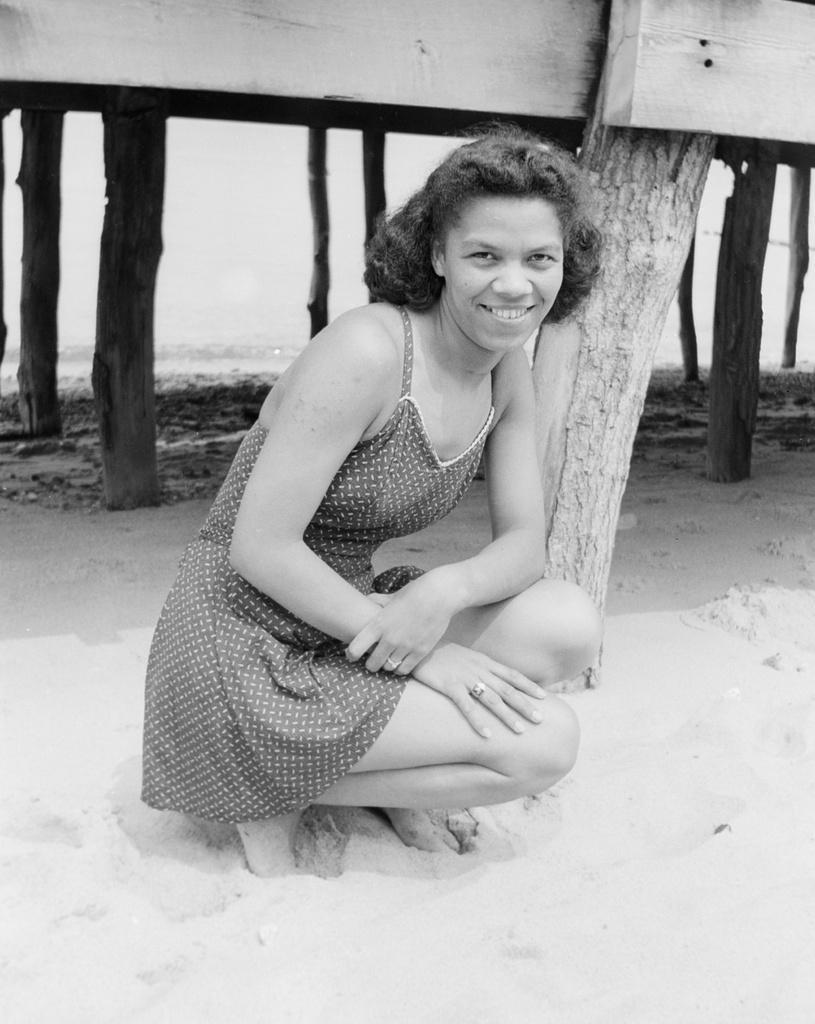Can you describe this image briefly? In this image I can see a woman and I can see smile on her face. In the background I can see few tree trunks. I can also see this image is black and white in colour. 